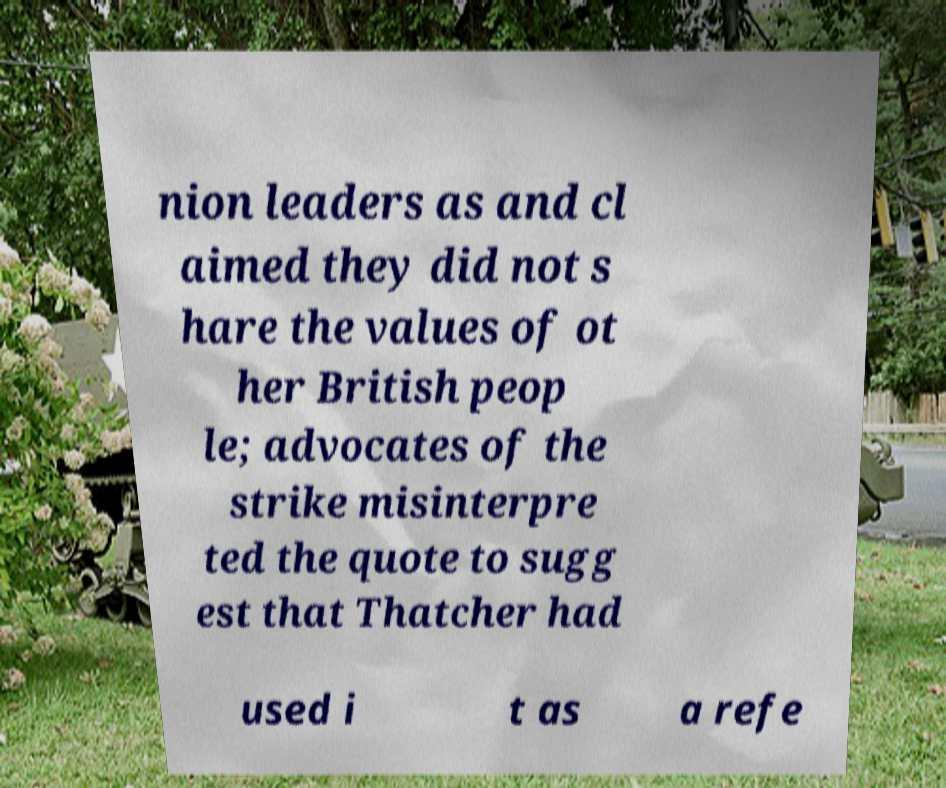Could you assist in decoding the text presented in this image and type it out clearly? nion leaders as and cl aimed they did not s hare the values of ot her British peop le; advocates of the strike misinterpre ted the quote to sugg est that Thatcher had used i t as a refe 